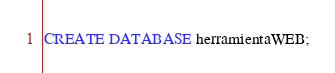Convert code to text. <code><loc_0><loc_0><loc_500><loc_500><_SQL_>CREATE DATABASE herramientaWEB;</code> 